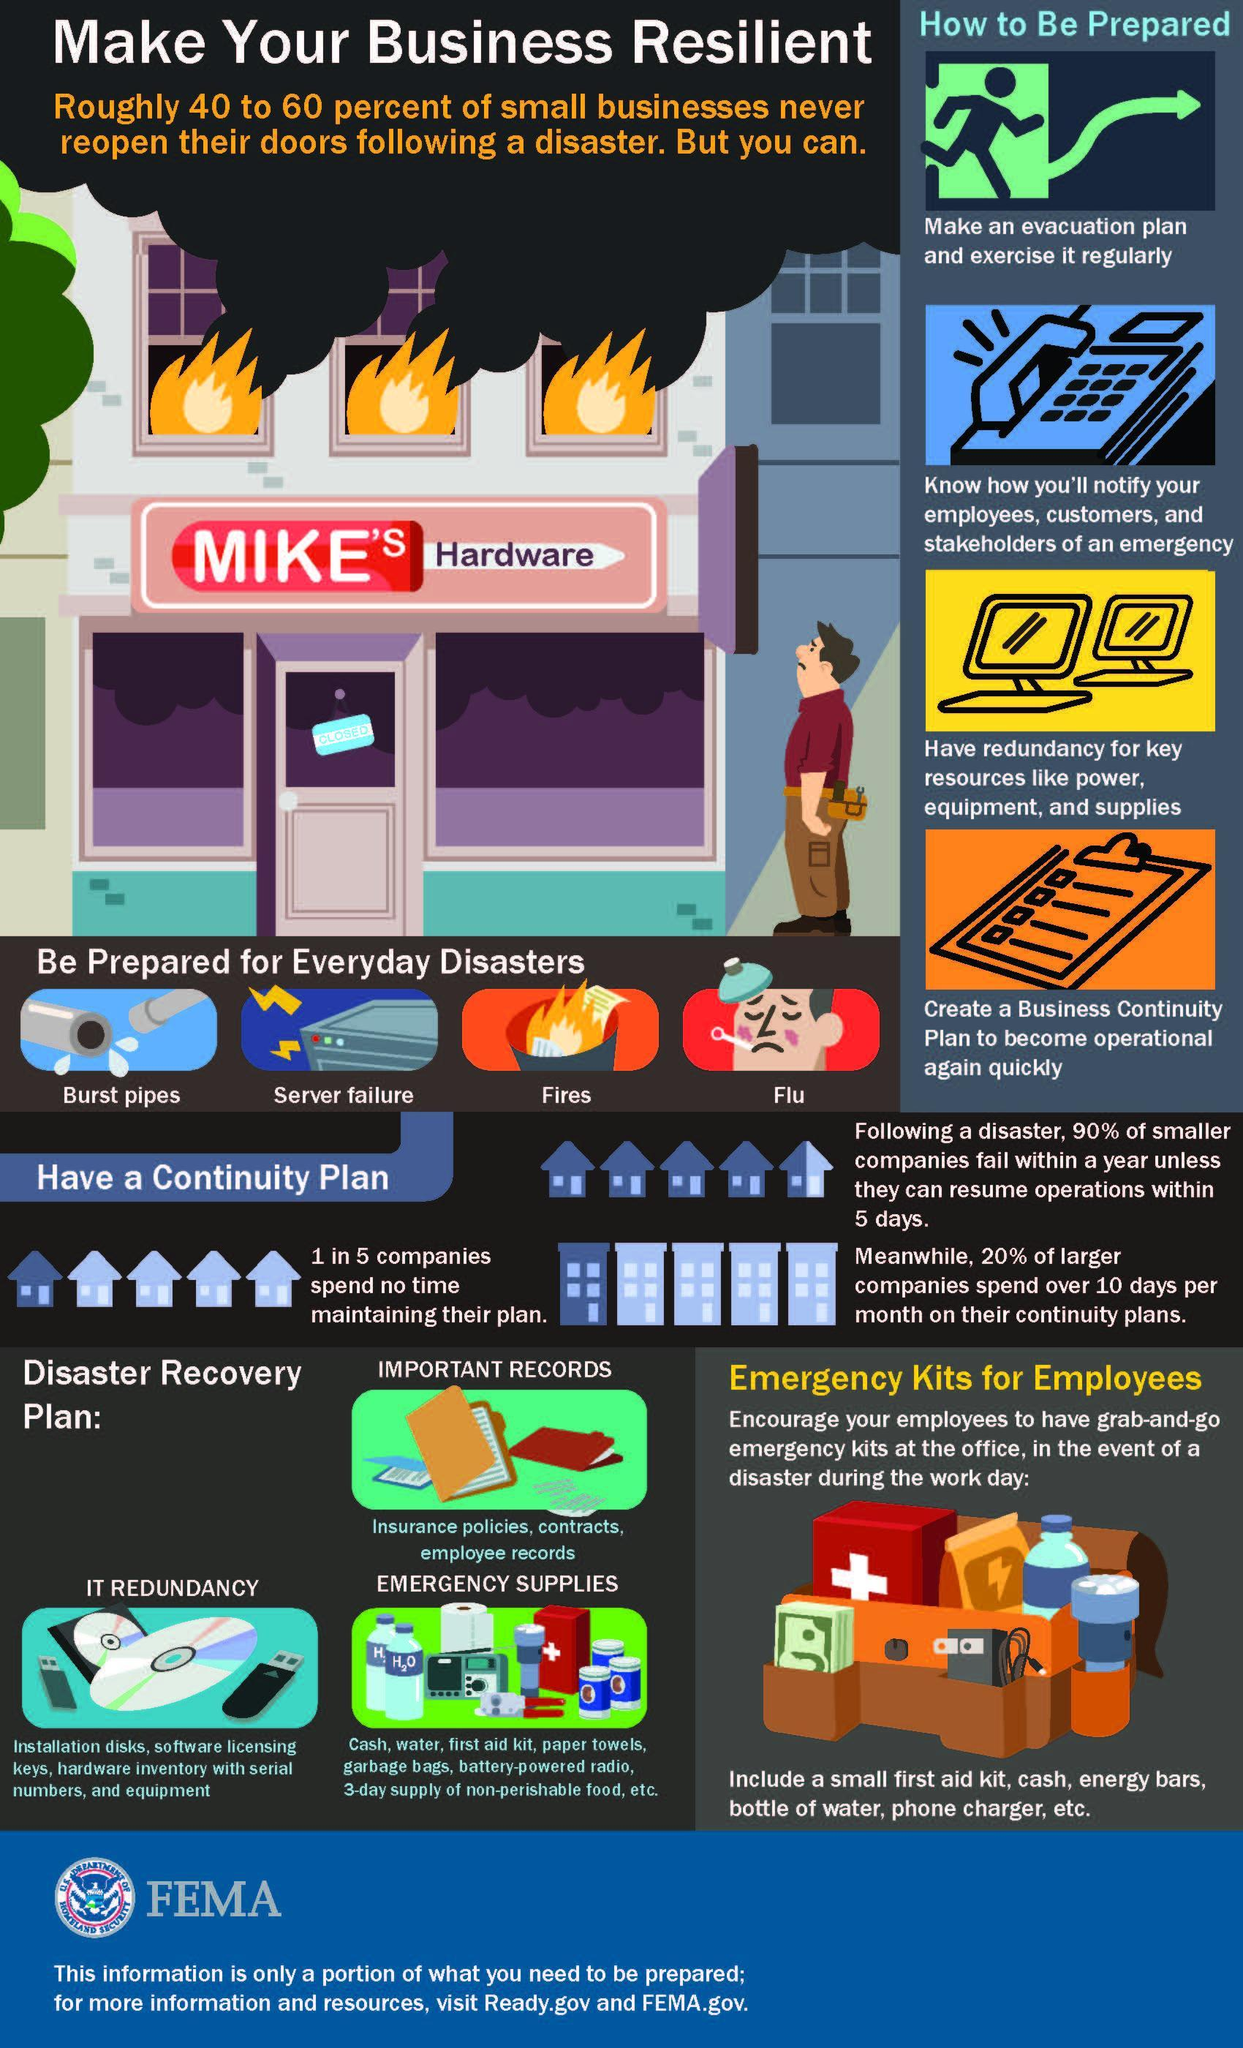Which is the third type of disaster that Mike's Hardware needs to be prepared for?
Answer the question with a short phrase. Fires 